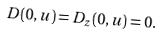Convert formula to latex. <formula><loc_0><loc_0><loc_500><loc_500>D ( 0 , u ) = D _ { z } ( 0 , u ) = 0 .</formula> 